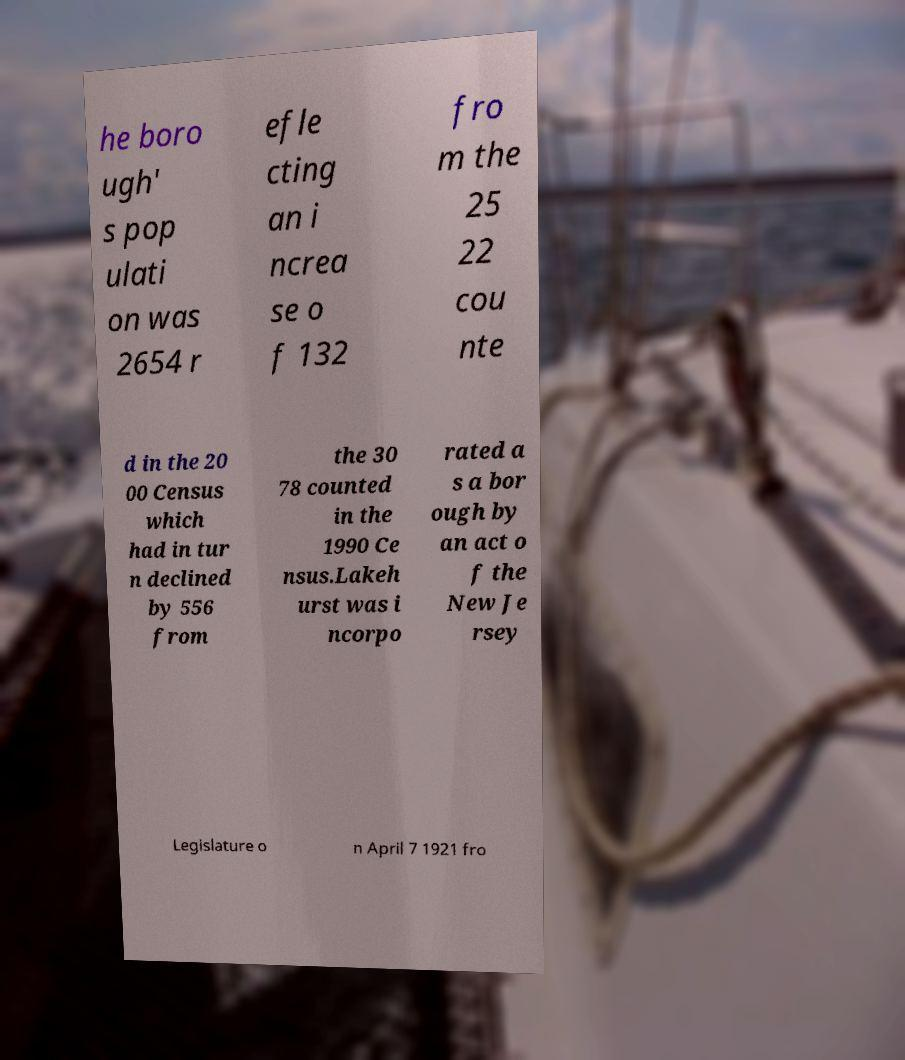I need the written content from this picture converted into text. Can you do that? he boro ugh' s pop ulati on was 2654 r efle cting an i ncrea se o f 132 fro m the 25 22 cou nte d in the 20 00 Census which had in tur n declined by 556 from the 30 78 counted in the 1990 Ce nsus.Lakeh urst was i ncorpo rated a s a bor ough by an act o f the New Je rsey Legislature o n April 7 1921 fro 